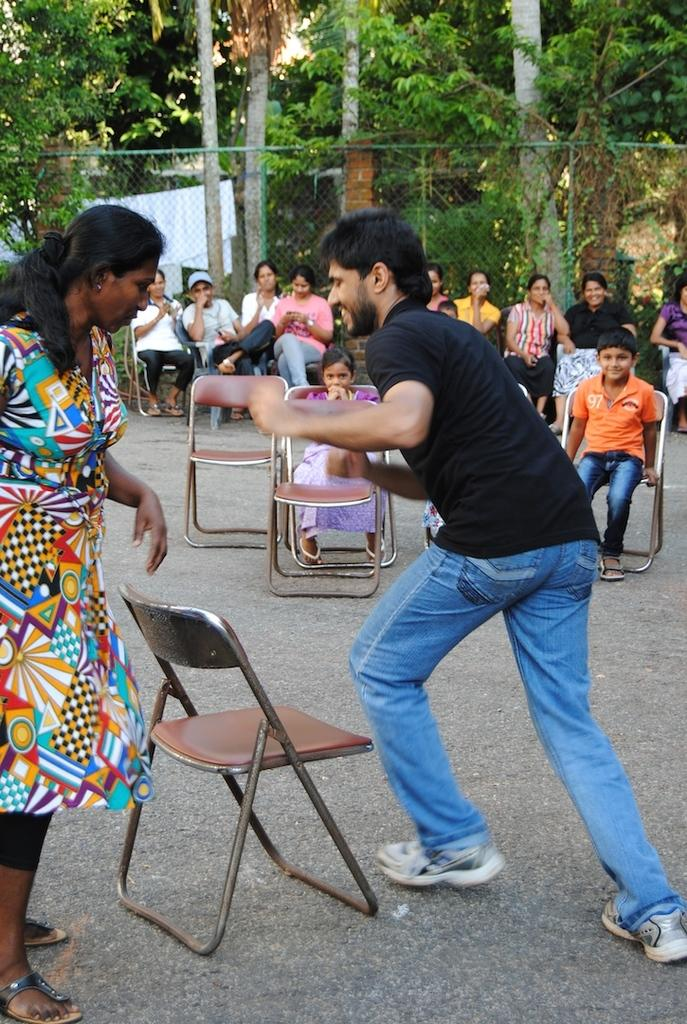What type of vegetation can be seen in the image? There are trees in the image. What is the purpose of the structure visible in the image? There is a fence in the image, which may serve as a boundary or barrier. What are the people in the image doing? There are people sitting on chairs in the image. Can you describe the unusual activity happening in the image? Two people are rotating around a chair in the image. What day of the week is it in the image? The day of the week cannot be determined from the image. Is there a crook present in the image? There is no crook present in the image. 